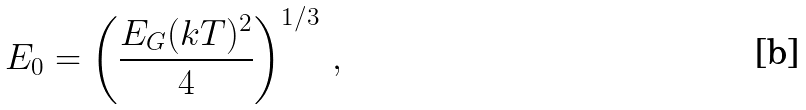<formula> <loc_0><loc_0><loc_500><loc_500>E _ { 0 } = \left ( \frac { E _ { G } ( k T ) ^ { 2 } } { 4 } \right ) ^ { 1 / 3 } \, ,</formula> 